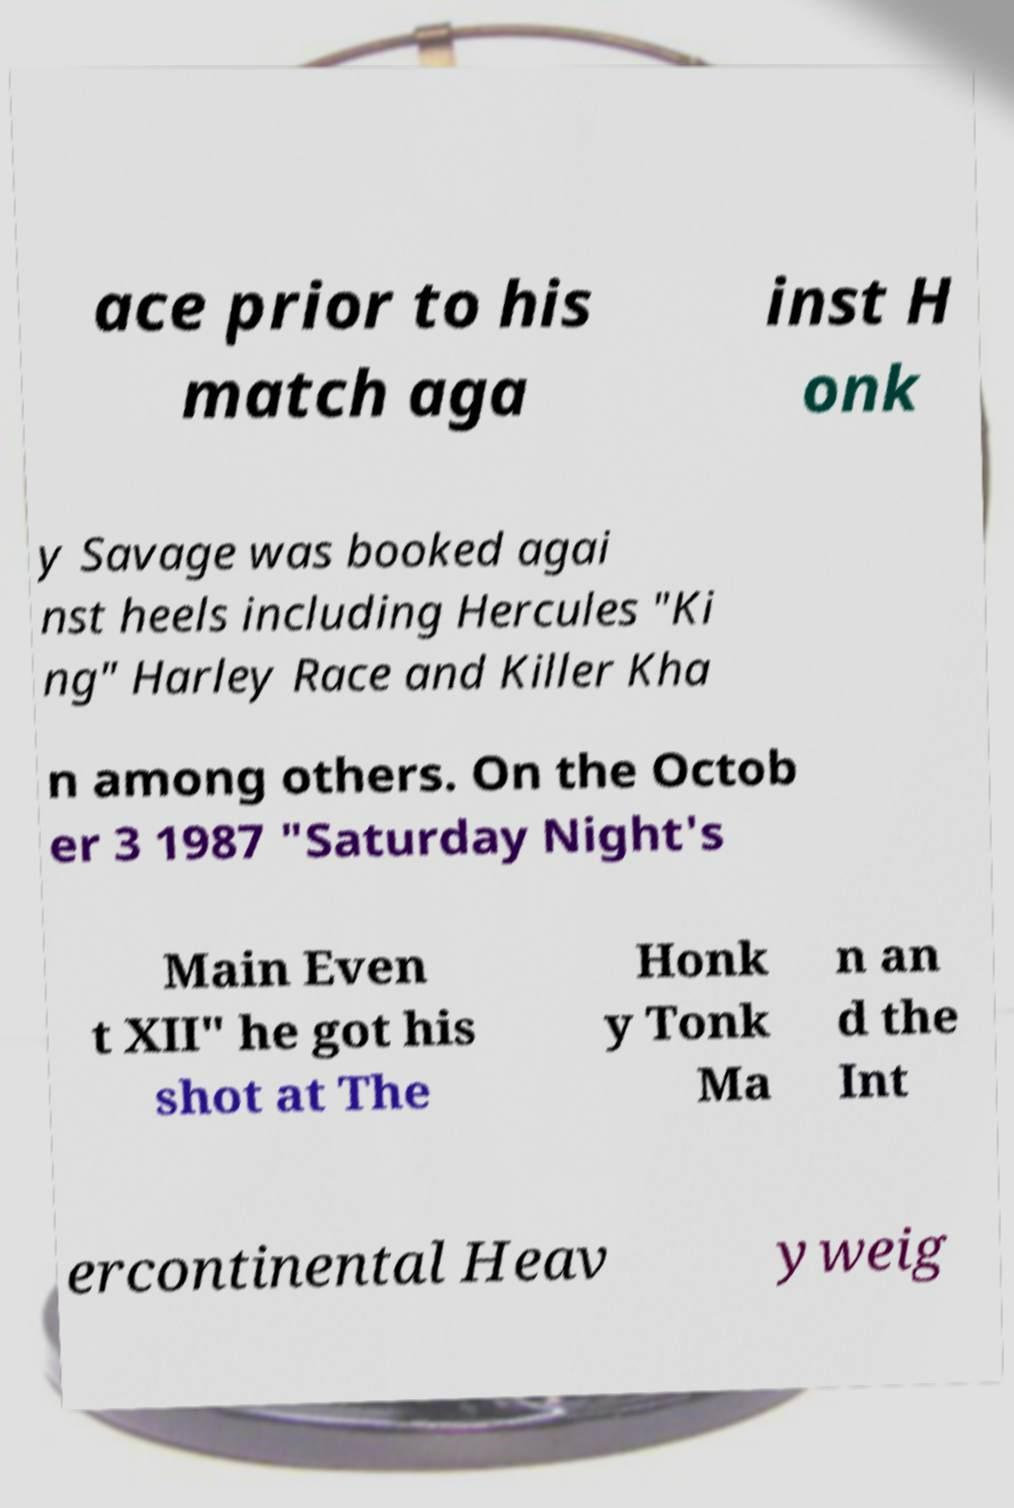Can you accurately transcribe the text from the provided image for me? ace prior to his match aga inst H onk y Savage was booked agai nst heels including Hercules "Ki ng" Harley Race and Killer Kha n among others. On the Octob er 3 1987 "Saturday Night's Main Even t XII" he got his shot at The Honk y Tonk Ma n an d the Int ercontinental Heav yweig 